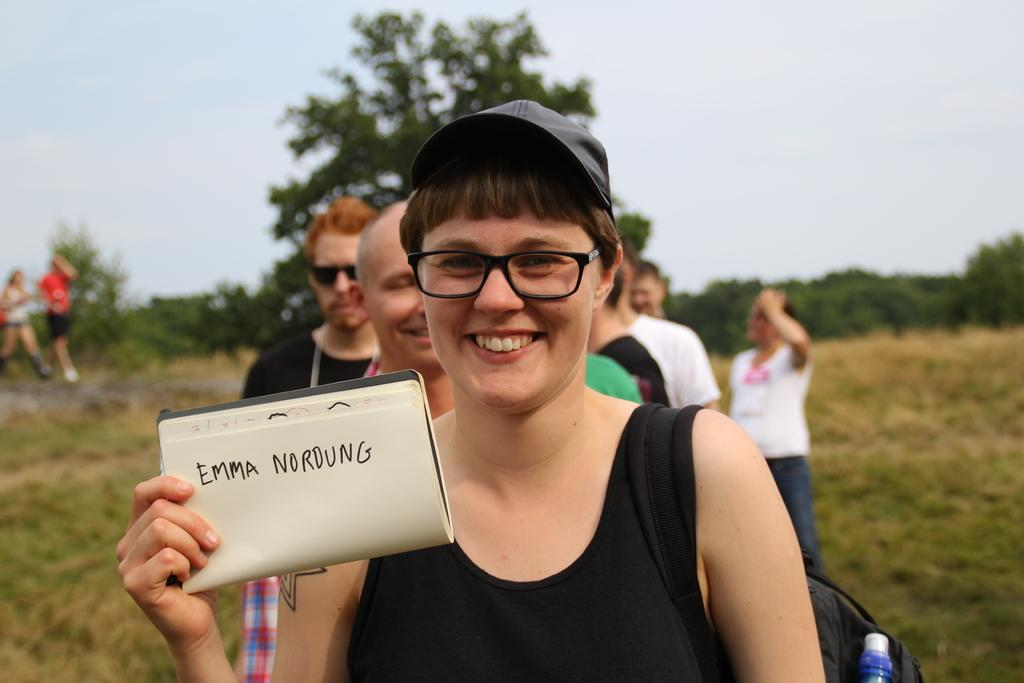Who is the main subject in the image? There is a woman in the image. What is the woman doing in the image? The woman is standing and smiling. What is the woman holding in the image? The woman is holding a book. Who else is present in the image? There are a group of people standing in the image. What type of natural environment is visible in the image? There are trees in the image, and the sky is visible in the background. What type of sidewalk can be seen in the image? There is no sidewalk present in the image. What emotion is the woman expressing in the image? The woman is smiling, which indicates a positive emotion, not anger. 